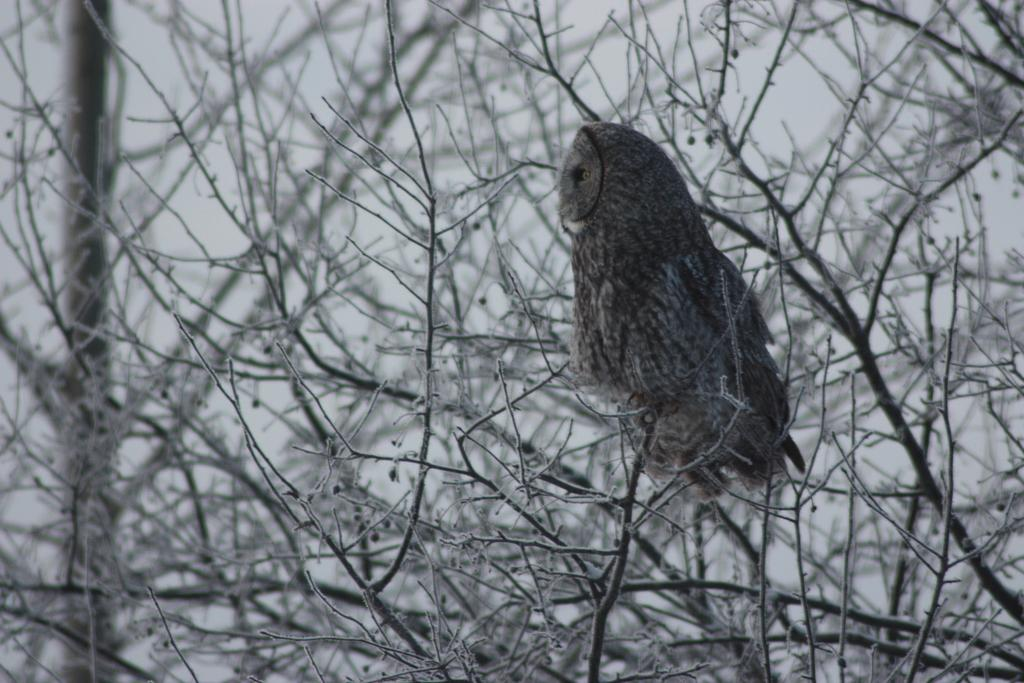What animal is present in the image? There is an owl in the image. What colors can be seen on the owl? The owl is white and black in color. Where is the owl located in the image? The owl is on a tree. What is the color of the tree? The tree is black and white in color. What can be seen in the background of the image? The sky is visible in the background of the image. What type of zephyr can be seen blowing through the owl's feathers in the image? There is no zephyr present in the image, and it does not show any wind blowing through the owl's feathers. 